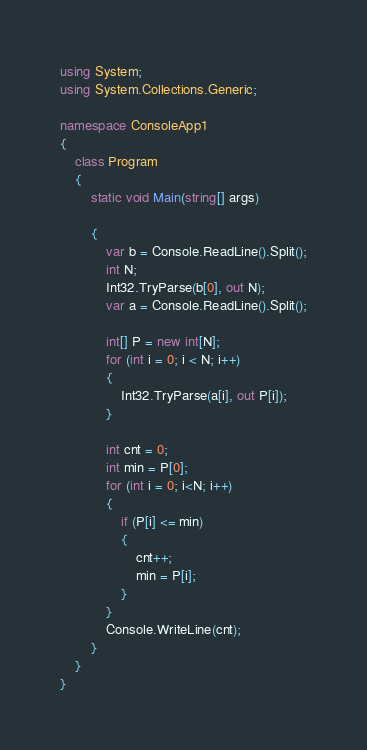<code> <loc_0><loc_0><loc_500><loc_500><_C#_>using System;
using System.Collections.Generic;

namespace ConsoleApp1
{
    class Program
    {
        static void Main(string[] args)

        {
            var b = Console.ReadLine().Split();
            int N;
            Int32.TryParse(b[0], out N);
            var a = Console.ReadLine().Split();

            int[] P = new int[N];
            for (int i = 0; i < N; i++)
            {
                Int32.TryParse(a[i], out P[i]);
            }

            int cnt = 0;
            int min = P[0];
            for (int i = 0; i<N; i++)
            {
                if (P[i] <= min)
                {
                    cnt++;
                    min = P[i];
                }
            }
            Console.WriteLine(cnt);
        }
    }
}
</code> 